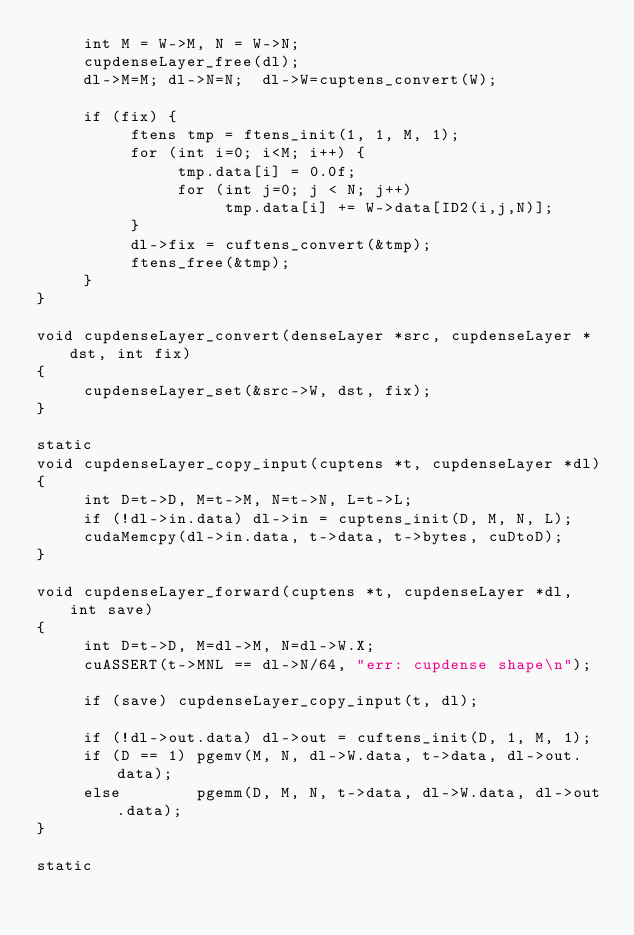<code> <loc_0><loc_0><loc_500><loc_500><_Cuda_>     int M = W->M, N = W->N;
     cupdenseLayer_free(dl);
     dl->M=M; dl->N=N;  dl->W=cuptens_convert(W);

     if (fix) {
          ftens tmp = ftens_init(1, 1, M, 1);
          for (int i=0; i<M; i++) {
               tmp.data[i] = 0.0f;
               for (int j=0; j < N; j++)
                    tmp.data[i] += W->data[ID2(i,j,N)];
          }
          dl->fix = cuftens_convert(&tmp);
          ftens_free(&tmp);
     }
}

void cupdenseLayer_convert(denseLayer *src, cupdenseLayer *dst, int fix)
{
     cupdenseLayer_set(&src->W, dst, fix);
}

static
void cupdenseLayer_copy_input(cuptens *t, cupdenseLayer *dl)
{
     int D=t->D, M=t->M, N=t->N, L=t->L;
     if (!dl->in.data) dl->in = cuptens_init(D, M, N, L);
     cudaMemcpy(dl->in.data, t->data, t->bytes, cuDtoD);
}

void cupdenseLayer_forward(cuptens *t, cupdenseLayer *dl, int save)
{
     int D=t->D, M=dl->M, N=dl->W.X;
     cuASSERT(t->MNL == dl->N/64, "err: cupdense shape\n");

     if (save) cupdenseLayer_copy_input(t, dl);

     if (!dl->out.data) dl->out = cuftens_init(D, 1, M, 1);
     if (D == 1) pgemv(M, N, dl->W.data, t->data, dl->out.data);
     else        pgemm(D, M, N, t->data, dl->W.data, dl->out.data);
}

static</code> 